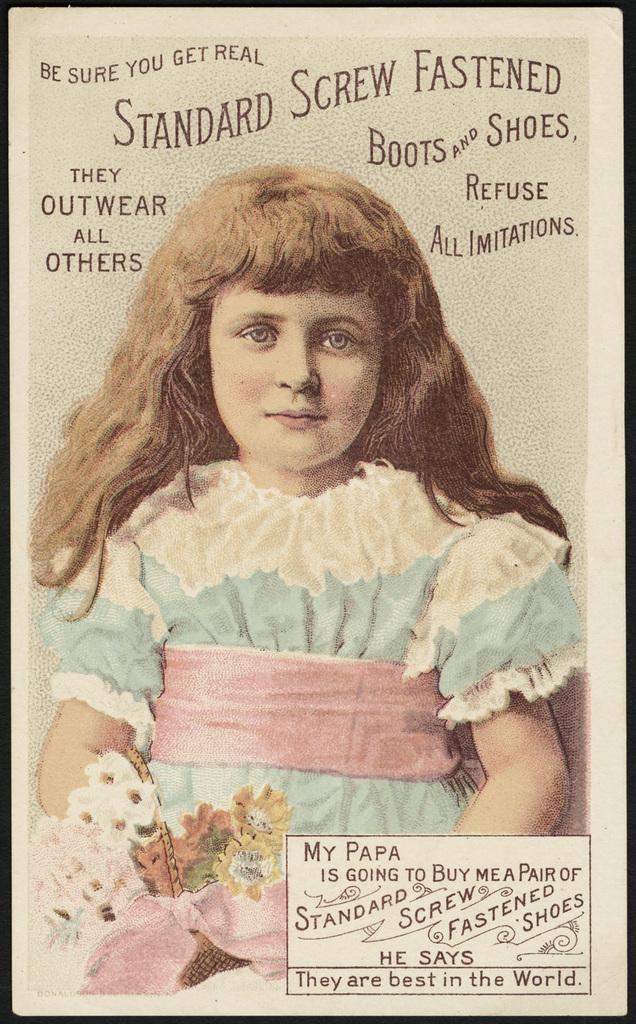What is present at the top of the image? There is text on the top of the image. What is present at the bottom of the image? There is text at the bottom of the image. Can you describe the person in the image? There is a person in the image, but no specific details about their appearance or actions are provided. What type of flora is present in the image? There are flowers in the image. Where are the flowers located in the image? The flowers are located in the bottom left of the image. What is the color of the image's borders? The image has black borders. Can you tell me how many basketballs are being held by the person in the image? There is no person holding a basketball in the image. What type of frog can be seen sitting on the flowers in the image? There are no frogs present in the image; it features flowers and text. 